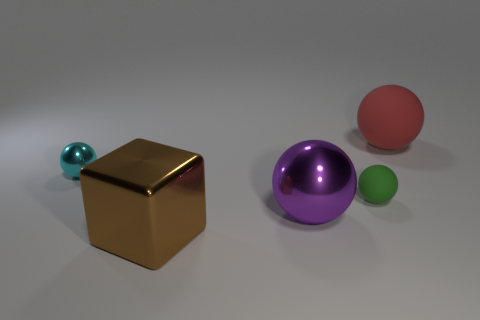Add 4 large brown metallic objects. How many objects exist? 9 Subtract all green matte spheres. How many spheres are left? 3 Subtract all red balls. How many balls are left? 3 Subtract all cubes. How many objects are left? 4 Subtract 3 balls. How many balls are left? 1 Subtract 0 brown cylinders. How many objects are left? 5 Subtract all purple blocks. Subtract all green spheres. How many blocks are left? 1 Subtract all gray cylinders. How many yellow balls are left? 0 Subtract all green rubber objects. Subtract all tiny purple cubes. How many objects are left? 4 Add 3 green rubber spheres. How many green rubber spheres are left? 4 